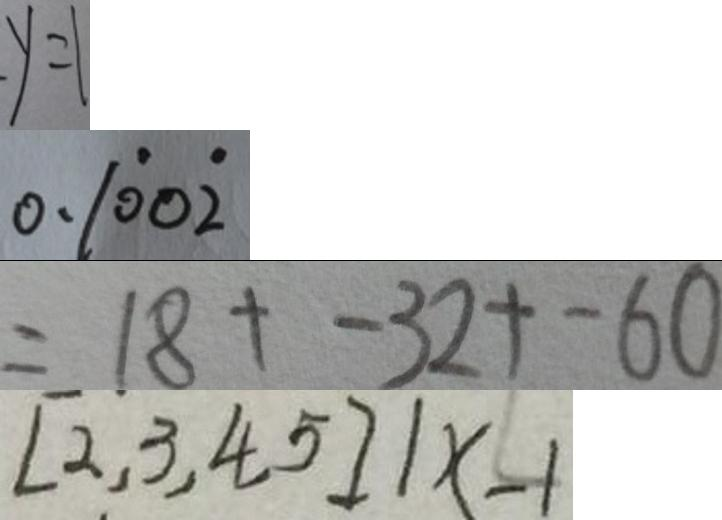Convert formula to latex. <formula><loc_0><loc_0><loc_500><loc_500>y = 1 
 0 . 1 \dot { 0 } 0 \dot { 2 } 
 = 1 8 + - 3 2 + - 6 0 
 [ 2 , 3 , 4 , 5 ] 1 x - 1</formula> 